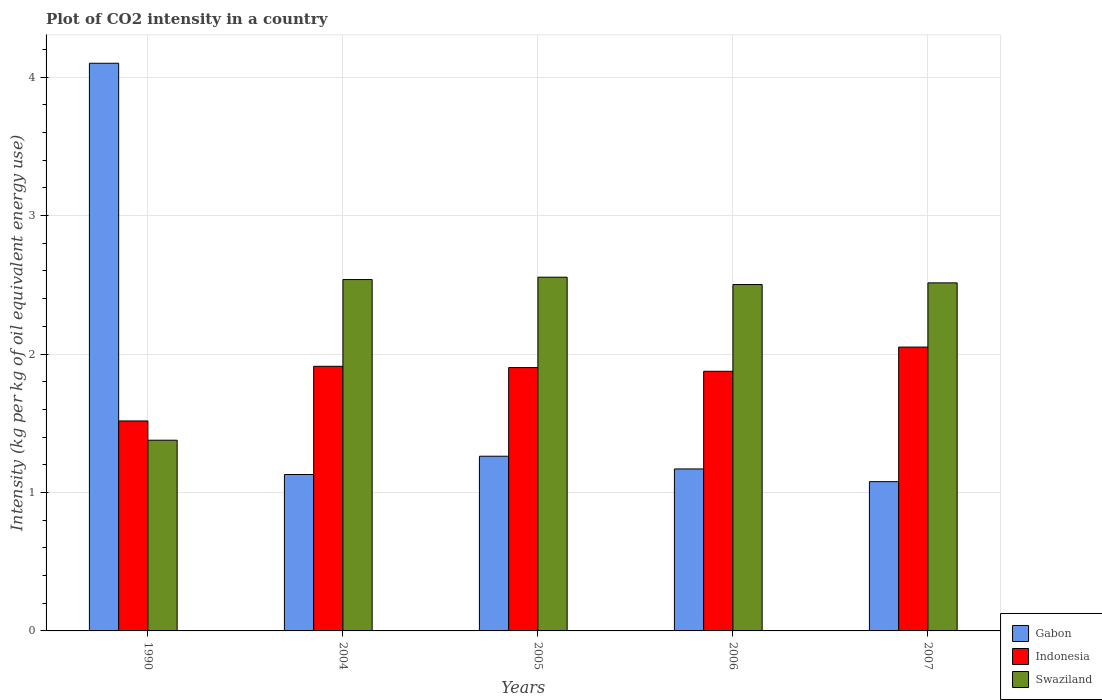How many different coloured bars are there?
Your answer should be very brief. 3. Are the number of bars per tick equal to the number of legend labels?
Ensure brevity in your answer.  Yes. Are the number of bars on each tick of the X-axis equal?
Offer a terse response. Yes. How many bars are there on the 3rd tick from the right?
Your answer should be very brief. 3. What is the label of the 1st group of bars from the left?
Ensure brevity in your answer.  1990. What is the CO2 intensity in in Indonesia in 2005?
Make the answer very short. 1.9. Across all years, what is the maximum CO2 intensity in in Swaziland?
Your answer should be compact. 2.55. Across all years, what is the minimum CO2 intensity in in Gabon?
Offer a very short reply. 1.08. In which year was the CO2 intensity in in Indonesia minimum?
Your response must be concise. 1990. What is the total CO2 intensity in in Gabon in the graph?
Provide a succinct answer. 8.74. What is the difference between the CO2 intensity in in Swaziland in 2005 and that in 2007?
Make the answer very short. 0.04. What is the difference between the CO2 intensity in in Swaziland in 2005 and the CO2 intensity in in Gabon in 2006?
Provide a short and direct response. 1.38. What is the average CO2 intensity in in Swaziland per year?
Give a very brief answer. 2.3. In the year 1990, what is the difference between the CO2 intensity in in Indonesia and CO2 intensity in in Gabon?
Keep it short and to the point. -2.58. What is the ratio of the CO2 intensity in in Gabon in 2005 to that in 2006?
Offer a very short reply. 1.08. What is the difference between the highest and the second highest CO2 intensity in in Gabon?
Give a very brief answer. 2.84. What is the difference between the highest and the lowest CO2 intensity in in Indonesia?
Your response must be concise. 0.53. In how many years, is the CO2 intensity in in Gabon greater than the average CO2 intensity in in Gabon taken over all years?
Provide a succinct answer. 1. Is the sum of the CO2 intensity in in Indonesia in 2004 and 2005 greater than the maximum CO2 intensity in in Gabon across all years?
Your response must be concise. No. What does the 1st bar from the left in 2006 represents?
Offer a terse response. Gabon. What does the 3rd bar from the right in 2006 represents?
Keep it short and to the point. Gabon. How many years are there in the graph?
Offer a terse response. 5. What is the difference between two consecutive major ticks on the Y-axis?
Make the answer very short. 1. Does the graph contain any zero values?
Your response must be concise. No. Does the graph contain grids?
Provide a short and direct response. Yes. Where does the legend appear in the graph?
Your response must be concise. Bottom right. What is the title of the graph?
Give a very brief answer. Plot of CO2 intensity in a country. What is the label or title of the X-axis?
Make the answer very short. Years. What is the label or title of the Y-axis?
Offer a very short reply. Intensity (kg per kg of oil equivalent energy use). What is the Intensity (kg per kg of oil equivalent energy use) in Gabon in 1990?
Give a very brief answer. 4.1. What is the Intensity (kg per kg of oil equivalent energy use) of Indonesia in 1990?
Offer a terse response. 1.52. What is the Intensity (kg per kg of oil equivalent energy use) in Swaziland in 1990?
Your answer should be very brief. 1.38. What is the Intensity (kg per kg of oil equivalent energy use) in Gabon in 2004?
Provide a succinct answer. 1.13. What is the Intensity (kg per kg of oil equivalent energy use) of Indonesia in 2004?
Your response must be concise. 1.91. What is the Intensity (kg per kg of oil equivalent energy use) of Swaziland in 2004?
Your answer should be very brief. 2.54. What is the Intensity (kg per kg of oil equivalent energy use) in Gabon in 2005?
Provide a succinct answer. 1.26. What is the Intensity (kg per kg of oil equivalent energy use) of Indonesia in 2005?
Give a very brief answer. 1.9. What is the Intensity (kg per kg of oil equivalent energy use) of Swaziland in 2005?
Make the answer very short. 2.55. What is the Intensity (kg per kg of oil equivalent energy use) of Gabon in 2006?
Your answer should be compact. 1.17. What is the Intensity (kg per kg of oil equivalent energy use) of Indonesia in 2006?
Your response must be concise. 1.88. What is the Intensity (kg per kg of oil equivalent energy use) of Swaziland in 2006?
Offer a terse response. 2.5. What is the Intensity (kg per kg of oil equivalent energy use) of Gabon in 2007?
Offer a terse response. 1.08. What is the Intensity (kg per kg of oil equivalent energy use) of Indonesia in 2007?
Make the answer very short. 2.05. What is the Intensity (kg per kg of oil equivalent energy use) of Swaziland in 2007?
Provide a short and direct response. 2.51. Across all years, what is the maximum Intensity (kg per kg of oil equivalent energy use) in Gabon?
Your answer should be compact. 4.1. Across all years, what is the maximum Intensity (kg per kg of oil equivalent energy use) in Indonesia?
Your answer should be compact. 2.05. Across all years, what is the maximum Intensity (kg per kg of oil equivalent energy use) of Swaziland?
Make the answer very short. 2.55. Across all years, what is the minimum Intensity (kg per kg of oil equivalent energy use) in Gabon?
Your answer should be very brief. 1.08. Across all years, what is the minimum Intensity (kg per kg of oil equivalent energy use) in Indonesia?
Your response must be concise. 1.52. Across all years, what is the minimum Intensity (kg per kg of oil equivalent energy use) of Swaziland?
Offer a terse response. 1.38. What is the total Intensity (kg per kg of oil equivalent energy use) in Gabon in the graph?
Offer a terse response. 8.74. What is the total Intensity (kg per kg of oil equivalent energy use) in Indonesia in the graph?
Ensure brevity in your answer.  9.26. What is the total Intensity (kg per kg of oil equivalent energy use) in Swaziland in the graph?
Make the answer very short. 11.49. What is the difference between the Intensity (kg per kg of oil equivalent energy use) of Gabon in 1990 and that in 2004?
Provide a short and direct response. 2.97. What is the difference between the Intensity (kg per kg of oil equivalent energy use) in Indonesia in 1990 and that in 2004?
Your response must be concise. -0.39. What is the difference between the Intensity (kg per kg of oil equivalent energy use) in Swaziland in 1990 and that in 2004?
Your answer should be compact. -1.16. What is the difference between the Intensity (kg per kg of oil equivalent energy use) in Gabon in 1990 and that in 2005?
Give a very brief answer. 2.84. What is the difference between the Intensity (kg per kg of oil equivalent energy use) in Indonesia in 1990 and that in 2005?
Give a very brief answer. -0.39. What is the difference between the Intensity (kg per kg of oil equivalent energy use) in Swaziland in 1990 and that in 2005?
Make the answer very short. -1.18. What is the difference between the Intensity (kg per kg of oil equivalent energy use) of Gabon in 1990 and that in 2006?
Your answer should be very brief. 2.93. What is the difference between the Intensity (kg per kg of oil equivalent energy use) of Indonesia in 1990 and that in 2006?
Make the answer very short. -0.36. What is the difference between the Intensity (kg per kg of oil equivalent energy use) in Swaziland in 1990 and that in 2006?
Give a very brief answer. -1.12. What is the difference between the Intensity (kg per kg of oil equivalent energy use) of Gabon in 1990 and that in 2007?
Provide a short and direct response. 3.02. What is the difference between the Intensity (kg per kg of oil equivalent energy use) of Indonesia in 1990 and that in 2007?
Your response must be concise. -0.53. What is the difference between the Intensity (kg per kg of oil equivalent energy use) in Swaziland in 1990 and that in 2007?
Make the answer very short. -1.14. What is the difference between the Intensity (kg per kg of oil equivalent energy use) in Gabon in 2004 and that in 2005?
Keep it short and to the point. -0.13. What is the difference between the Intensity (kg per kg of oil equivalent energy use) in Indonesia in 2004 and that in 2005?
Your answer should be very brief. 0.01. What is the difference between the Intensity (kg per kg of oil equivalent energy use) in Swaziland in 2004 and that in 2005?
Keep it short and to the point. -0.02. What is the difference between the Intensity (kg per kg of oil equivalent energy use) of Gabon in 2004 and that in 2006?
Give a very brief answer. -0.04. What is the difference between the Intensity (kg per kg of oil equivalent energy use) in Indonesia in 2004 and that in 2006?
Keep it short and to the point. 0.04. What is the difference between the Intensity (kg per kg of oil equivalent energy use) in Swaziland in 2004 and that in 2006?
Ensure brevity in your answer.  0.04. What is the difference between the Intensity (kg per kg of oil equivalent energy use) in Gabon in 2004 and that in 2007?
Offer a terse response. 0.05. What is the difference between the Intensity (kg per kg of oil equivalent energy use) of Indonesia in 2004 and that in 2007?
Your response must be concise. -0.14. What is the difference between the Intensity (kg per kg of oil equivalent energy use) in Swaziland in 2004 and that in 2007?
Keep it short and to the point. 0.02. What is the difference between the Intensity (kg per kg of oil equivalent energy use) of Gabon in 2005 and that in 2006?
Offer a very short reply. 0.09. What is the difference between the Intensity (kg per kg of oil equivalent energy use) in Indonesia in 2005 and that in 2006?
Make the answer very short. 0.03. What is the difference between the Intensity (kg per kg of oil equivalent energy use) in Swaziland in 2005 and that in 2006?
Provide a succinct answer. 0.05. What is the difference between the Intensity (kg per kg of oil equivalent energy use) of Gabon in 2005 and that in 2007?
Your answer should be compact. 0.18. What is the difference between the Intensity (kg per kg of oil equivalent energy use) in Indonesia in 2005 and that in 2007?
Provide a short and direct response. -0.15. What is the difference between the Intensity (kg per kg of oil equivalent energy use) of Swaziland in 2005 and that in 2007?
Provide a succinct answer. 0.04. What is the difference between the Intensity (kg per kg of oil equivalent energy use) of Gabon in 2006 and that in 2007?
Give a very brief answer. 0.09. What is the difference between the Intensity (kg per kg of oil equivalent energy use) in Indonesia in 2006 and that in 2007?
Offer a terse response. -0.17. What is the difference between the Intensity (kg per kg of oil equivalent energy use) of Swaziland in 2006 and that in 2007?
Your response must be concise. -0.01. What is the difference between the Intensity (kg per kg of oil equivalent energy use) of Gabon in 1990 and the Intensity (kg per kg of oil equivalent energy use) of Indonesia in 2004?
Provide a succinct answer. 2.19. What is the difference between the Intensity (kg per kg of oil equivalent energy use) in Gabon in 1990 and the Intensity (kg per kg of oil equivalent energy use) in Swaziland in 2004?
Offer a terse response. 1.56. What is the difference between the Intensity (kg per kg of oil equivalent energy use) in Indonesia in 1990 and the Intensity (kg per kg of oil equivalent energy use) in Swaziland in 2004?
Your answer should be compact. -1.02. What is the difference between the Intensity (kg per kg of oil equivalent energy use) of Gabon in 1990 and the Intensity (kg per kg of oil equivalent energy use) of Indonesia in 2005?
Your answer should be very brief. 2.2. What is the difference between the Intensity (kg per kg of oil equivalent energy use) in Gabon in 1990 and the Intensity (kg per kg of oil equivalent energy use) in Swaziland in 2005?
Give a very brief answer. 1.55. What is the difference between the Intensity (kg per kg of oil equivalent energy use) of Indonesia in 1990 and the Intensity (kg per kg of oil equivalent energy use) of Swaziland in 2005?
Offer a terse response. -1.04. What is the difference between the Intensity (kg per kg of oil equivalent energy use) of Gabon in 1990 and the Intensity (kg per kg of oil equivalent energy use) of Indonesia in 2006?
Your response must be concise. 2.22. What is the difference between the Intensity (kg per kg of oil equivalent energy use) of Gabon in 1990 and the Intensity (kg per kg of oil equivalent energy use) of Swaziland in 2006?
Provide a succinct answer. 1.6. What is the difference between the Intensity (kg per kg of oil equivalent energy use) of Indonesia in 1990 and the Intensity (kg per kg of oil equivalent energy use) of Swaziland in 2006?
Your answer should be very brief. -0.99. What is the difference between the Intensity (kg per kg of oil equivalent energy use) of Gabon in 1990 and the Intensity (kg per kg of oil equivalent energy use) of Indonesia in 2007?
Give a very brief answer. 2.05. What is the difference between the Intensity (kg per kg of oil equivalent energy use) in Gabon in 1990 and the Intensity (kg per kg of oil equivalent energy use) in Swaziland in 2007?
Offer a terse response. 1.59. What is the difference between the Intensity (kg per kg of oil equivalent energy use) in Indonesia in 1990 and the Intensity (kg per kg of oil equivalent energy use) in Swaziland in 2007?
Your answer should be very brief. -1. What is the difference between the Intensity (kg per kg of oil equivalent energy use) in Gabon in 2004 and the Intensity (kg per kg of oil equivalent energy use) in Indonesia in 2005?
Provide a succinct answer. -0.77. What is the difference between the Intensity (kg per kg of oil equivalent energy use) of Gabon in 2004 and the Intensity (kg per kg of oil equivalent energy use) of Swaziland in 2005?
Offer a terse response. -1.43. What is the difference between the Intensity (kg per kg of oil equivalent energy use) in Indonesia in 2004 and the Intensity (kg per kg of oil equivalent energy use) in Swaziland in 2005?
Offer a very short reply. -0.64. What is the difference between the Intensity (kg per kg of oil equivalent energy use) in Gabon in 2004 and the Intensity (kg per kg of oil equivalent energy use) in Indonesia in 2006?
Offer a terse response. -0.75. What is the difference between the Intensity (kg per kg of oil equivalent energy use) of Gabon in 2004 and the Intensity (kg per kg of oil equivalent energy use) of Swaziland in 2006?
Provide a short and direct response. -1.37. What is the difference between the Intensity (kg per kg of oil equivalent energy use) in Indonesia in 2004 and the Intensity (kg per kg of oil equivalent energy use) in Swaziland in 2006?
Ensure brevity in your answer.  -0.59. What is the difference between the Intensity (kg per kg of oil equivalent energy use) in Gabon in 2004 and the Intensity (kg per kg of oil equivalent energy use) in Indonesia in 2007?
Keep it short and to the point. -0.92. What is the difference between the Intensity (kg per kg of oil equivalent energy use) of Gabon in 2004 and the Intensity (kg per kg of oil equivalent energy use) of Swaziland in 2007?
Keep it short and to the point. -1.38. What is the difference between the Intensity (kg per kg of oil equivalent energy use) of Indonesia in 2004 and the Intensity (kg per kg of oil equivalent energy use) of Swaziland in 2007?
Provide a short and direct response. -0.6. What is the difference between the Intensity (kg per kg of oil equivalent energy use) of Gabon in 2005 and the Intensity (kg per kg of oil equivalent energy use) of Indonesia in 2006?
Keep it short and to the point. -0.61. What is the difference between the Intensity (kg per kg of oil equivalent energy use) in Gabon in 2005 and the Intensity (kg per kg of oil equivalent energy use) in Swaziland in 2006?
Offer a terse response. -1.24. What is the difference between the Intensity (kg per kg of oil equivalent energy use) in Indonesia in 2005 and the Intensity (kg per kg of oil equivalent energy use) in Swaziland in 2006?
Give a very brief answer. -0.6. What is the difference between the Intensity (kg per kg of oil equivalent energy use) in Gabon in 2005 and the Intensity (kg per kg of oil equivalent energy use) in Indonesia in 2007?
Offer a very short reply. -0.79. What is the difference between the Intensity (kg per kg of oil equivalent energy use) of Gabon in 2005 and the Intensity (kg per kg of oil equivalent energy use) of Swaziland in 2007?
Your answer should be compact. -1.25. What is the difference between the Intensity (kg per kg of oil equivalent energy use) in Indonesia in 2005 and the Intensity (kg per kg of oil equivalent energy use) in Swaziland in 2007?
Keep it short and to the point. -0.61. What is the difference between the Intensity (kg per kg of oil equivalent energy use) of Gabon in 2006 and the Intensity (kg per kg of oil equivalent energy use) of Indonesia in 2007?
Offer a terse response. -0.88. What is the difference between the Intensity (kg per kg of oil equivalent energy use) in Gabon in 2006 and the Intensity (kg per kg of oil equivalent energy use) in Swaziland in 2007?
Offer a terse response. -1.34. What is the difference between the Intensity (kg per kg of oil equivalent energy use) of Indonesia in 2006 and the Intensity (kg per kg of oil equivalent energy use) of Swaziland in 2007?
Make the answer very short. -0.64. What is the average Intensity (kg per kg of oil equivalent energy use) in Gabon per year?
Offer a very short reply. 1.75. What is the average Intensity (kg per kg of oil equivalent energy use) of Indonesia per year?
Give a very brief answer. 1.85. What is the average Intensity (kg per kg of oil equivalent energy use) in Swaziland per year?
Keep it short and to the point. 2.3. In the year 1990, what is the difference between the Intensity (kg per kg of oil equivalent energy use) in Gabon and Intensity (kg per kg of oil equivalent energy use) in Indonesia?
Ensure brevity in your answer.  2.58. In the year 1990, what is the difference between the Intensity (kg per kg of oil equivalent energy use) of Gabon and Intensity (kg per kg of oil equivalent energy use) of Swaziland?
Ensure brevity in your answer.  2.72. In the year 1990, what is the difference between the Intensity (kg per kg of oil equivalent energy use) in Indonesia and Intensity (kg per kg of oil equivalent energy use) in Swaziland?
Your answer should be very brief. 0.14. In the year 2004, what is the difference between the Intensity (kg per kg of oil equivalent energy use) in Gabon and Intensity (kg per kg of oil equivalent energy use) in Indonesia?
Your answer should be compact. -0.78. In the year 2004, what is the difference between the Intensity (kg per kg of oil equivalent energy use) of Gabon and Intensity (kg per kg of oil equivalent energy use) of Swaziland?
Make the answer very short. -1.41. In the year 2004, what is the difference between the Intensity (kg per kg of oil equivalent energy use) in Indonesia and Intensity (kg per kg of oil equivalent energy use) in Swaziland?
Your response must be concise. -0.63. In the year 2005, what is the difference between the Intensity (kg per kg of oil equivalent energy use) in Gabon and Intensity (kg per kg of oil equivalent energy use) in Indonesia?
Ensure brevity in your answer.  -0.64. In the year 2005, what is the difference between the Intensity (kg per kg of oil equivalent energy use) of Gabon and Intensity (kg per kg of oil equivalent energy use) of Swaziland?
Ensure brevity in your answer.  -1.29. In the year 2005, what is the difference between the Intensity (kg per kg of oil equivalent energy use) of Indonesia and Intensity (kg per kg of oil equivalent energy use) of Swaziland?
Keep it short and to the point. -0.65. In the year 2006, what is the difference between the Intensity (kg per kg of oil equivalent energy use) in Gabon and Intensity (kg per kg of oil equivalent energy use) in Indonesia?
Keep it short and to the point. -0.71. In the year 2006, what is the difference between the Intensity (kg per kg of oil equivalent energy use) of Gabon and Intensity (kg per kg of oil equivalent energy use) of Swaziland?
Make the answer very short. -1.33. In the year 2006, what is the difference between the Intensity (kg per kg of oil equivalent energy use) in Indonesia and Intensity (kg per kg of oil equivalent energy use) in Swaziland?
Offer a very short reply. -0.63. In the year 2007, what is the difference between the Intensity (kg per kg of oil equivalent energy use) in Gabon and Intensity (kg per kg of oil equivalent energy use) in Indonesia?
Your response must be concise. -0.97. In the year 2007, what is the difference between the Intensity (kg per kg of oil equivalent energy use) in Gabon and Intensity (kg per kg of oil equivalent energy use) in Swaziland?
Give a very brief answer. -1.44. In the year 2007, what is the difference between the Intensity (kg per kg of oil equivalent energy use) in Indonesia and Intensity (kg per kg of oil equivalent energy use) in Swaziland?
Offer a very short reply. -0.46. What is the ratio of the Intensity (kg per kg of oil equivalent energy use) in Gabon in 1990 to that in 2004?
Provide a short and direct response. 3.63. What is the ratio of the Intensity (kg per kg of oil equivalent energy use) in Indonesia in 1990 to that in 2004?
Your answer should be compact. 0.79. What is the ratio of the Intensity (kg per kg of oil equivalent energy use) in Swaziland in 1990 to that in 2004?
Your answer should be compact. 0.54. What is the ratio of the Intensity (kg per kg of oil equivalent energy use) in Gabon in 1990 to that in 2005?
Give a very brief answer. 3.25. What is the ratio of the Intensity (kg per kg of oil equivalent energy use) in Indonesia in 1990 to that in 2005?
Offer a very short reply. 0.8. What is the ratio of the Intensity (kg per kg of oil equivalent energy use) in Swaziland in 1990 to that in 2005?
Keep it short and to the point. 0.54. What is the ratio of the Intensity (kg per kg of oil equivalent energy use) of Gabon in 1990 to that in 2006?
Provide a succinct answer. 3.5. What is the ratio of the Intensity (kg per kg of oil equivalent energy use) of Indonesia in 1990 to that in 2006?
Your response must be concise. 0.81. What is the ratio of the Intensity (kg per kg of oil equivalent energy use) of Swaziland in 1990 to that in 2006?
Keep it short and to the point. 0.55. What is the ratio of the Intensity (kg per kg of oil equivalent energy use) of Gabon in 1990 to that in 2007?
Provide a short and direct response. 3.8. What is the ratio of the Intensity (kg per kg of oil equivalent energy use) in Indonesia in 1990 to that in 2007?
Your response must be concise. 0.74. What is the ratio of the Intensity (kg per kg of oil equivalent energy use) in Swaziland in 1990 to that in 2007?
Provide a short and direct response. 0.55. What is the ratio of the Intensity (kg per kg of oil equivalent energy use) of Gabon in 2004 to that in 2005?
Provide a short and direct response. 0.9. What is the ratio of the Intensity (kg per kg of oil equivalent energy use) in Indonesia in 2004 to that in 2005?
Offer a terse response. 1. What is the ratio of the Intensity (kg per kg of oil equivalent energy use) in Swaziland in 2004 to that in 2005?
Your response must be concise. 0.99. What is the ratio of the Intensity (kg per kg of oil equivalent energy use) of Gabon in 2004 to that in 2006?
Provide a short and direct response. 0.97. What is the ratio of the Intensity (kg per kg of oil equivalent energy use) of Indonesia in 2004 to that in 2006?
Your answer should be very brief. 1.02. What is the ratio of the Intensity (kg per kg of oil equivalent energy use) of Swaziland in 2004 to that in 2006?
Keep it short and to the point. 1.01. What is the ratio of the Intensity (kg per kg of oil equivalent energy use) of Gabon in 2004 to that in 2007?
Ensure brevity in your answer.  1.05. What is the ratio of the Intensity (kg per kg of oil equivalent energy use) of Indonesia in 2004 to that in 2007?
Give a very brief answer. 0.93. What is the ratio of the Intensity (kg per kg of oil equivalent energy use) in Swaziland in 2004 to that in 2007?
Provide a succinct answer. 1.01. What is the ratio of the Intensity (kg per kg of oil equivalent energy use) of Gabon in 2005 to that in 2006?
Your answer should be compact. 1.08. What is the ratio of the Intensity (kg per kg of oil equivalent energy use) in Indonesia in 2005 to that in 2006?
Provide a short and direct response. 1.01. What is the ratio of the Intensity (kg per kg of oil equivalent energy use) of Swaziland in 2005 to that in 2006?
Give a very brief answer. 1.02. What is the ratio of the Intensity (kg per kg of oil equivalent energy use) in Gabon in 2005 to that in 2007?
Your answer should be compact. 1.17. What is the ratio of the Intensity (kg per kg of oil equivalent energy use) in Indonesia in 2005 to that in 2007?
Offer a very short reply. 0.93. What is the ratio of the Intensity (kg per kg of oil equivalent energy use) in Swaziland in 2005 to that in 2007?
Ensure brevity in your answer.  1.02. What is the ratio of the Intensity (kg per kg of oil equivalent energy use) in Gabon in 2006 to that in 2007?
Offer a very short reply. 1.09. What is the ratio of the Intensity (kg per kg of oil equivalent energy use) of Indonesia in 2006 to that in 2007?
Your answer should be very brief. 0.91. What is the ratio of the Intensity (kg per kg of oil equivalent energy use) of Swaziland in 2006 to that in 2007?
Your answer should be very brief. 1. What is the difference between the highest and the second highest Intensity (kg per kg of oil equivalent energy use) in Gabon?
Your answer should be compact. 2.84. What is the difference between the highest and the second highest Intensity (kg per kg of oil equivalent energy use) in Indonesia?
Provide a short and direct response. 0.14. What is the difference between the highest and the second highest Intensity (kg per kg of oil equivalent energy use) of Swaziland?
Give a very brief answer. 0.02. What is the difference between the highest and the lowest Intensity (kg per kg of oil equivalent energy use) of Gabon?
Offer a terse response. 3.02. What is the difference between the highest and the lowest Intensity (kg per kg of oil equivalent energy use) of Indonesia?
Provide a succinct answer. 0.53. What is the difference between the highest and the lowest Intensity (kg per kg of oil equivalent energy use) of Swaziland?
Your response must be concise. 1.18. 